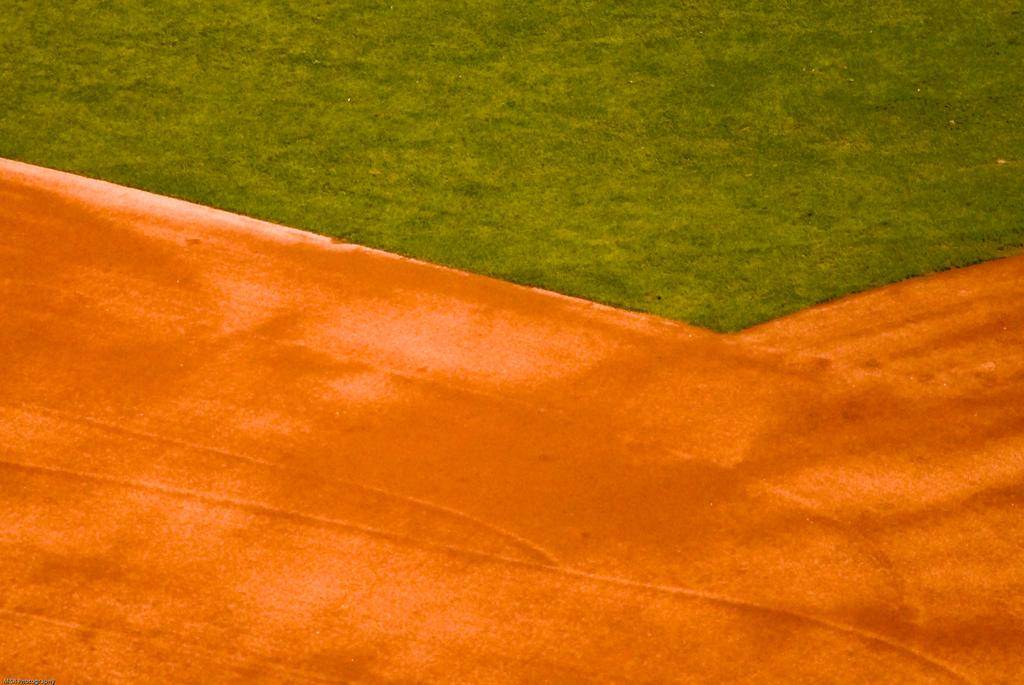What type of vegetation is present in the image? There is grass in the image. Where is the grass located? The grass appears to be on a ground. What type of apparatus can be seen hanging from the icicle in the image? There is no apparatus or icicle present in the image; it only features grass on a ground. 